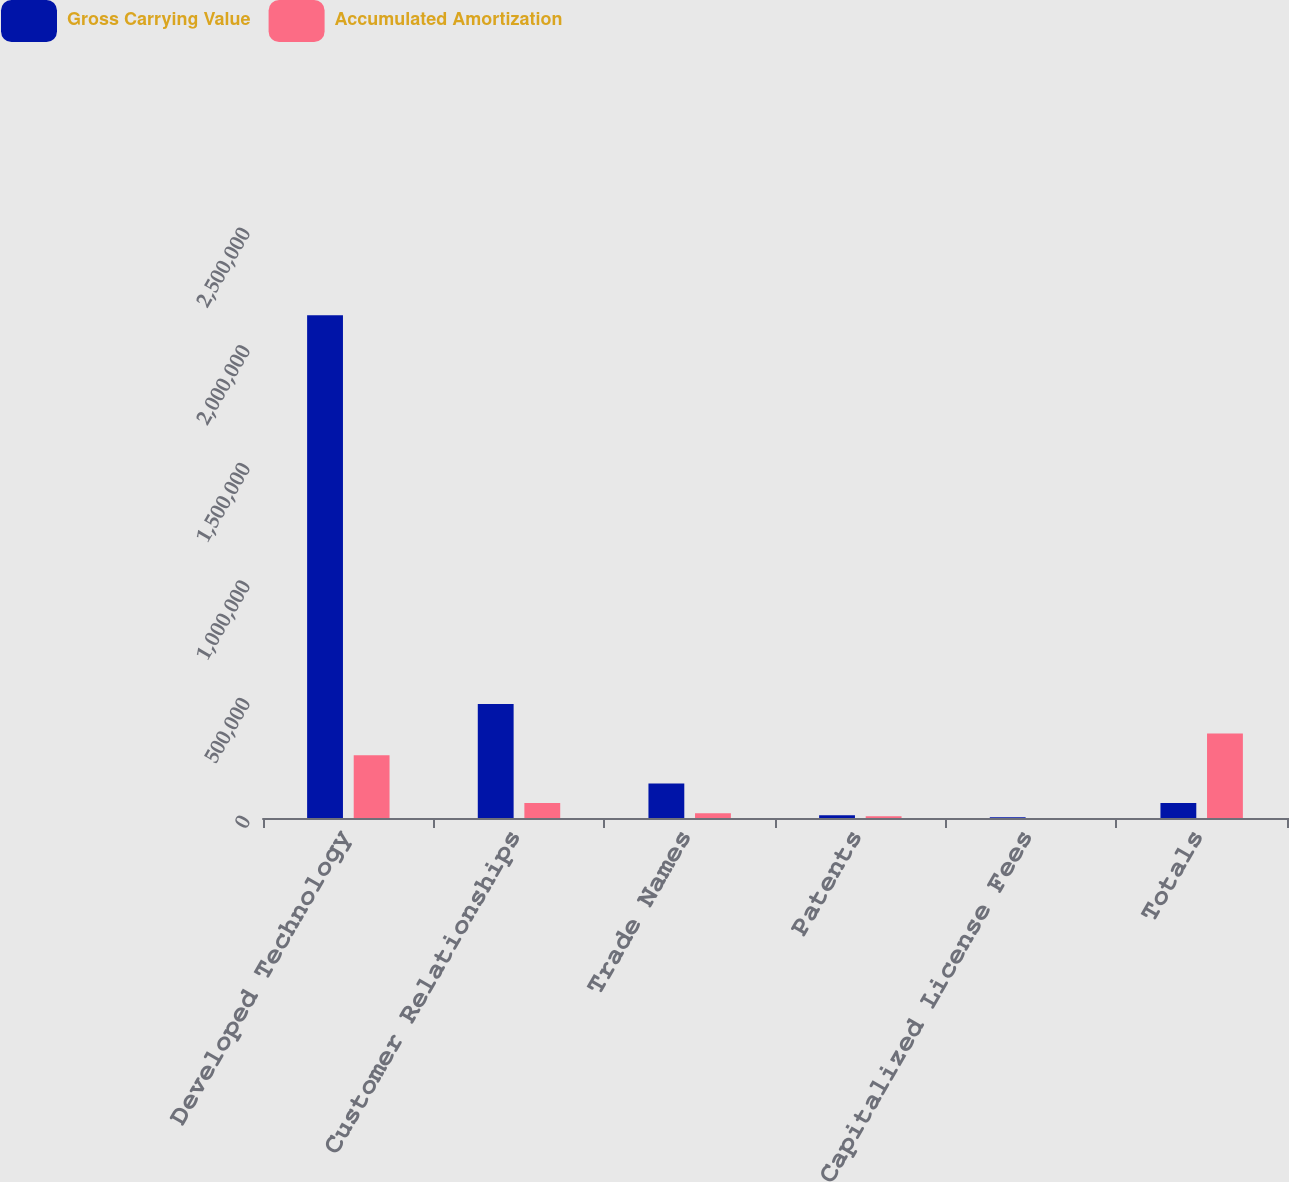<chart> <loc_0><loc_0><loc_500><loc_500><stacked_bar_chart><ecel><fcel>Developed Technology<fcel>Customer Relationships<fcel>Trade Names<fcel>Patents<fcel>Capitalized License Fees<fcel>Totals<nl><fcel>Gross Carrying Value<fcel>2.13771e+06<fcel>484993<fcel>146965<fcel>11513<fcel>2766<fcel>63494<nl><fcel>Accumulated Amortization<fcel>267259<fcel>63494<fcel>20094<fcel>7771<fcel>518<fcel>359136<nl></chart> 